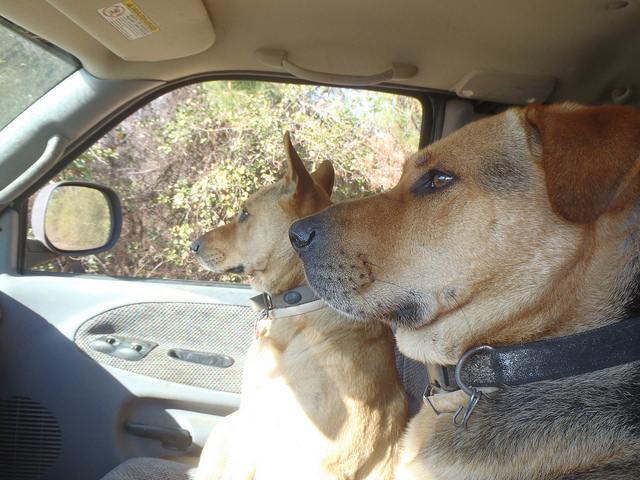<image>Is the background of a city? No, the background is not of a city. Is the background of a city? The background is not a city. 